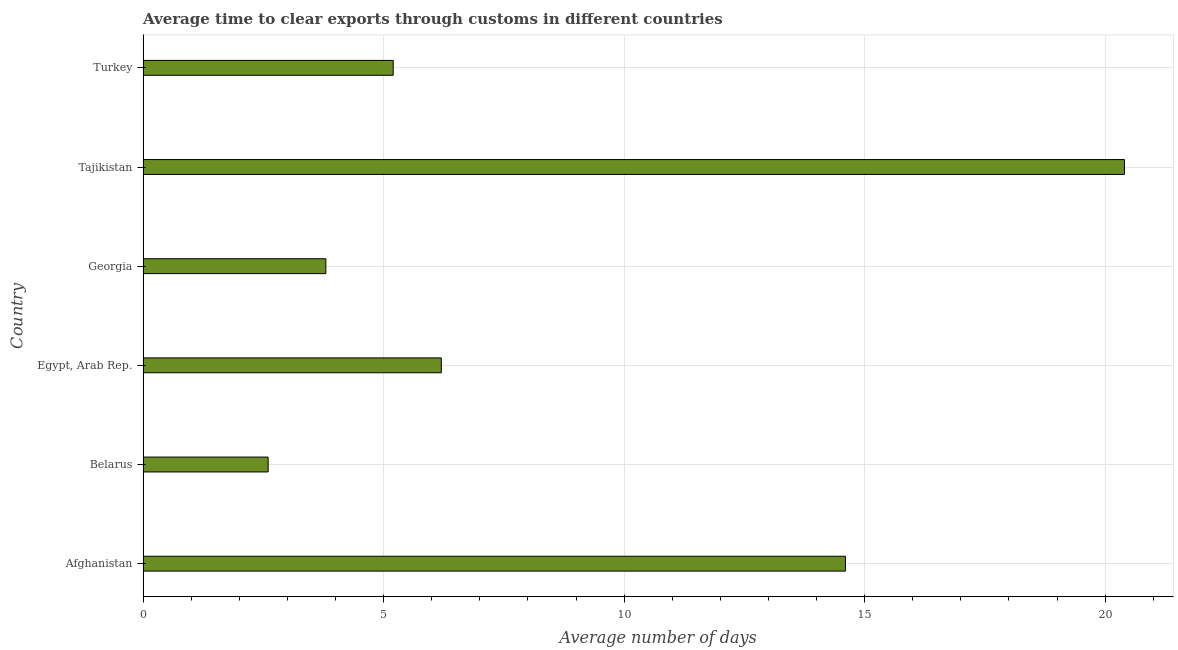What is the title of the graph?
Offer a very short reply. Average time to clear exports through customs in different countries. What is the label or title of the X-axis?
Ensure brevity in your answer.  Average number of days. Across all countries, what is the maximum time to clear exports through customs?
Provide a short and direct response. 20.4. Across all countries, what is the minimum time to clear exports through customs?
Your answer should be compact. 2.6. In which country was the time to clear exports through customs maximum?
Your answer should be very brief. Tajikistan. In which country was the time to clear exports through customs minimum?
Offer a very short reply. Belarus. What is the sum of the time to clear exports through customs?
Your answer should be compact. 52.8. What is the difference between the time to clear exports through customs in Afghanistan and Belarus?
Your answer should be very brief. 12. What is the median time to clear exports through customs?
Keep it short and to the point. 5.7. What is the ratio of the time to clear exports through customs in Afghanistan to that in Tajikistan?
Offer a very short reply. 0.72. Is the sum of the time to clear exports through customs in Afghanistan and Turkey greater than the maximum time to clear exports through customs across all countries?
Make the answer very short. No. Are all the bars in the graph horizontal?
Ensure brevity in your answer.  Yes. What is the difference between two consecutive major ticks on the X-axis?
Your response must be concise. 5. Are the values on the major ticks of X-axis written in scientific E-notation?
Your answer should be compact. No. What is the Average number of days of Afghanistan?
Your answer should be very brief. 14.6. What is the Average number of days of Belarus?
Offer a terse response. 2.6. What is the Average number of days in Egypt, Arab Rep.?
Your answer should be very brief. 6.2. What is the Average number of days of Georgia?
Offer a terse response. 3.8. What is the Average number of days in Tajikistan?
Give a very brief answer. 20.4. What is the difference between the Average number of days in Afghanistan and Egypt, Arab Rep.?
Your answer should be compact. 8.4. What is the difference between the Average number of days in Afghanistan and Georgia?
Your answer should be compact. 10.8. What is the difference between the Average number of days in Afghanistan and Tajikistan?
Your response must be concise. -5.8. What is the difference between the Average number of days in Belarus and Egypt, Arab Rep.?
Your answer should be compact. -3.6. What is the difference between the Average number of days in Belarus and Tajikistan?
Provide a succinct answer. -17.8. What is the difference between the Average number of days in Belarus and Turkey?
Ensure brevity in your answer.  -2.6. What is the difference between the Average number of days in Egypt, Arab Rep. and Georgia?
Ensure brevity in your answer.  2.4. What is the difference between the Average number of days in Egypt, Arab Rep. and Tajikistan?
Provide a succinct answer. -14.2. What is the difference between the Average number of days in Georgia and Tajikistan?
Your answer should be very brief. -16.6. What is the difference between the Average number of days in Tajikistan and Turkey?
Give a very brief answer. 15.2. What is the ratio of the Average number of days in Afghanistan to that in Belarus?
Make the answer very short. 5.62. What is the ratio of the Average number of days in Afghanistan to that in Egypt, Arab Rep.?
Ensure brevity in your answer.  2.35. What is the ratio of the Average number of days in Afghanistan to that in Georgia?
Give a very brief answer. 3.84. What is the ratio of the Average number of days in Afghanistan to that in Tajikistan?
Ensure brevity in your answer.  0.72. What is the ratio of the Average number of days in Afghanistan to that in Turkey?
Ensure brevity in your answer.  2.81. What is the ratio of the Average number of days in Belarus to that in Egypt, Arab Rep.?
Give a very brief answer. 0.42. What is the ratio of the Average number of days in Belarus to that in Georgia?
Make the answer very short. 0.68. What is the ratio of the Average number of days in Belarus to that in Tajikistan?
Give a very brief answer. 0.13. What is the ratio of the Average number of days in Egypt, Arab Rep. to that in Georgia?
Your response must be concise. 1.63. What is the ratio of the Average number of days in Egypt, Arab Rep. to that in Tajikistan?
Give a very brief answer. 0.3. What is the ratio of the Average number of days in Egypt, Arab Rep. to that in Turkey?
Your answer should be compact. 1.19. What is the ratio of the Average number of days in Georgia to that in Tajikistan?
Provide a short and direct response. 0.19. What is the ratio of the Average number of days in Georgia to that in Turkey?
Keep it short and to the point. 0.73. What is the ratio of the Average number of days in Tajikistan to that in Turkey?
Offer a terse response. 3.92. 